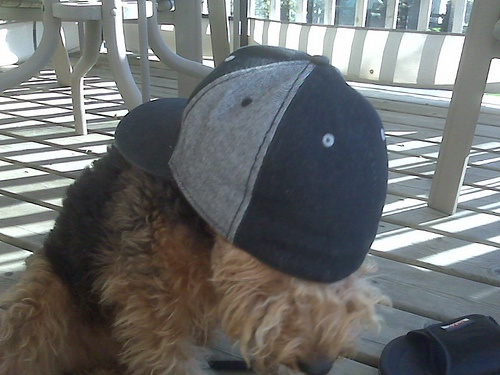Describe the objects in this image and their specific colors. I can see dog in gray, black, and maroon tones, chair in gray, darkgray, and white tones, and chair in gray and white tones in this image. 